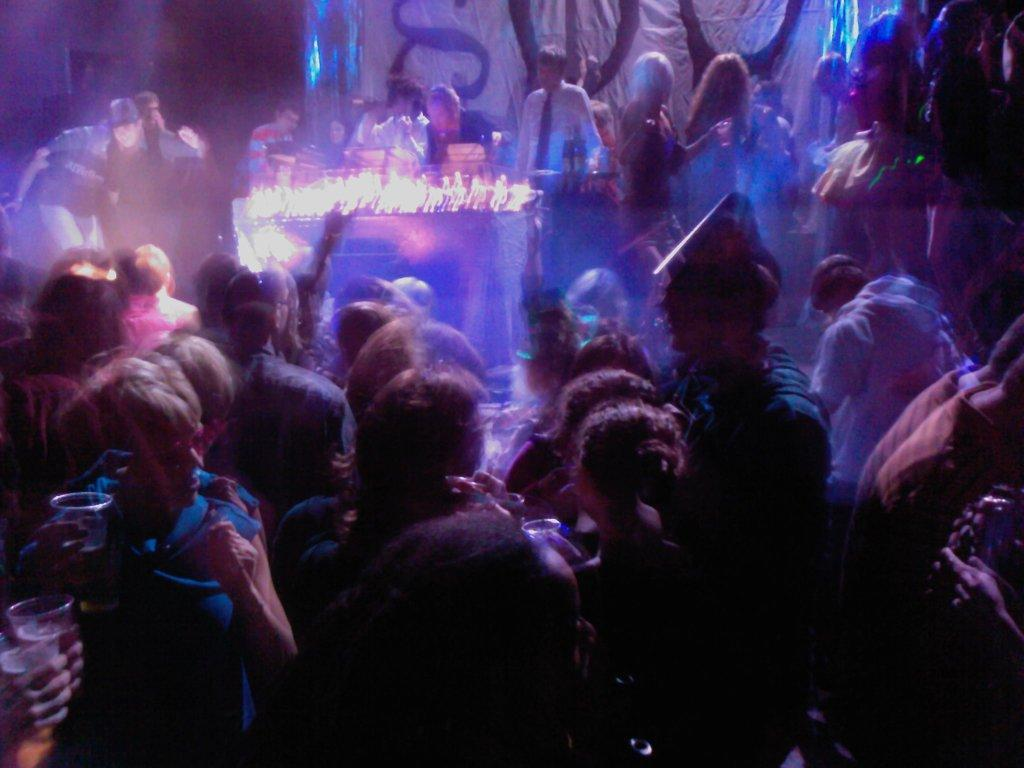Who or what is present in the image? There are people in the image. What object can be seen in the image that might be used for eating or working? There is a table in the image. What is placed on top of the table in the image? There are lights on top of the table. What can be seen in the background of the image? There is a banner in the background of the image. What account number is written on the banner in the image? There is no account number present on the banner in the image. 